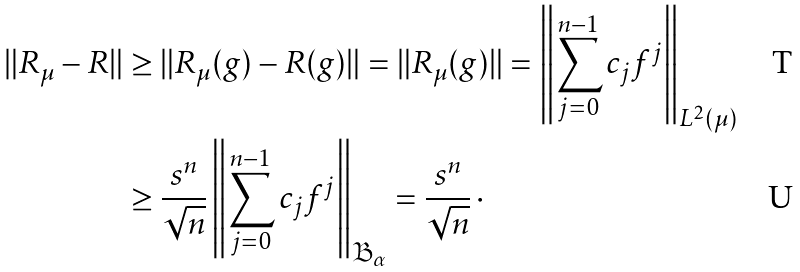<formula> <loc_0><loc_0><loc_500><loc_500>\| R _ { \mu } - R \| & \geq \| R _ { \mu } ( g ) - R ( g ) \| = \| R _ { \mu } ( g ) \| = \left \| \sum _ { j = 0 } ^ { n - 1 } c _ { j } f ^ { j } \right \| _ { L ^ { 2 } ( \mu ) } \\ & \geq \frac { s ^ { n } } { \sqrt { n } } \left \| \sum _ { j = 0 } ^ { n - 1 } c _ { j } f ^ { j } \right \| _ { { \mathfrak B } _ { \alpha } } = \frac { s ^ { n } } { \sqrt { n } } \, \cdot</formula> 